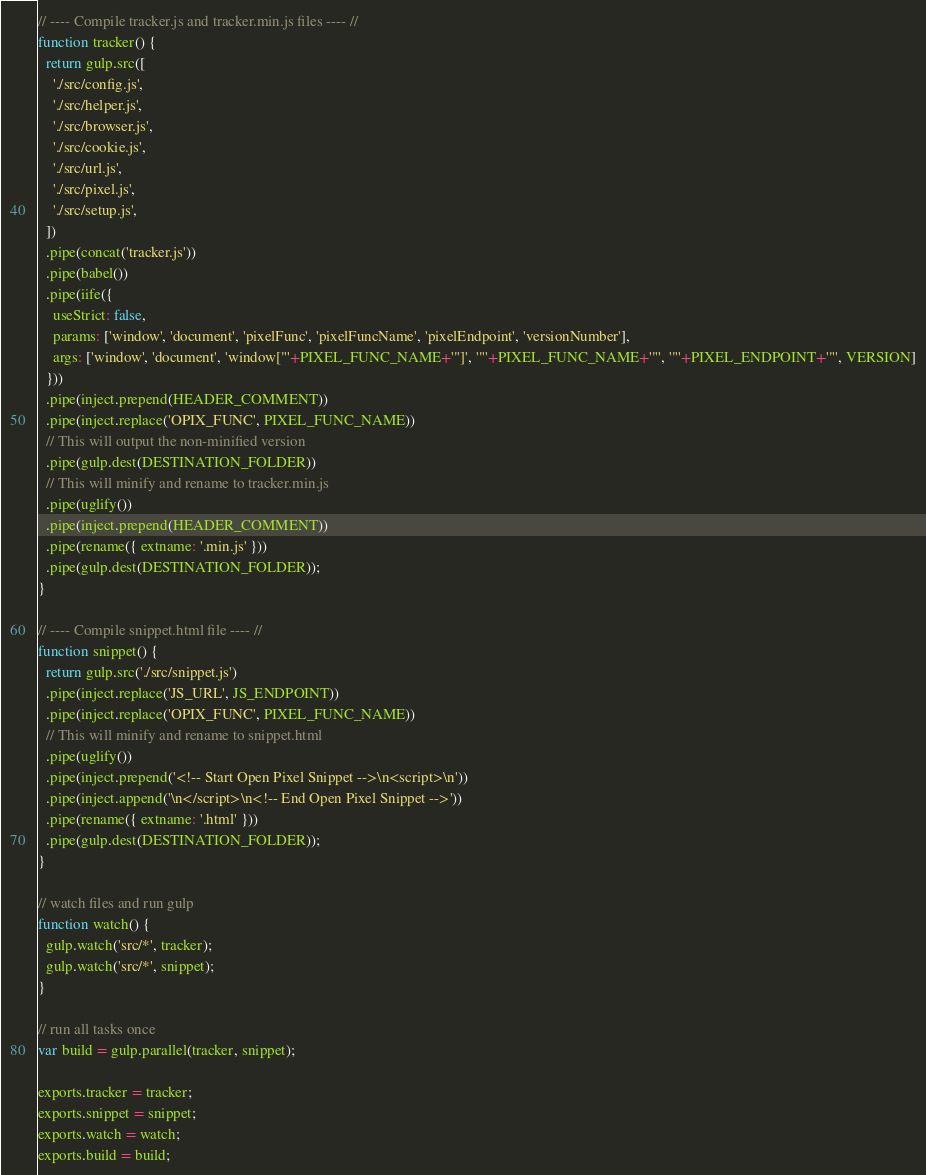<code> <loc_0><loc_0><loc_500><loc_500><_JavaScript_>// ---- Compile tracker.js and tracker.min.js files ---- //
function tracker() {
  return gulp.src([
    './src/config.js',
    './src/helper.js',
    './src/browser.js',
    './src/cookie.js',
    './src/url.js',
    './src/pixel.js',
    './src/setup.js',
  ])
  .pipe(concat('tracker.js'))
  .pipe(babel())
  .pipe(iife({
    useStrict: false,
    params: ['window', 'document', 'pixelFunc', 'pixelFuncName', 'pixelEndpoint', 'versionNumber'],
    args: ['window', 'document', 'window["'+PIXEL_FUNC_NAME+'"]', '"'+PIXEL_FUNC_NAME+'"', '"'+PIXEL_ENDPOINT+'"', VERSION]
  }))
  .pipe(inject.prepend(HEADER_COMMENT))
  .pipe(inject.replace('OPIX_FUNC', PIXEL_FUNC_NAME))
  // This will output the non-minified version
  .pipe(gulp.dest(DESTINATION_FOLDER))
  // This will minify and rename to tracker.min.js
  .pipe(uglify())
  .pipe(inject.prepend(HEADER_COMMENT))
  .pipe(rename({ extname: '.min.js' }))
  .pipe(gulp.dest(DESTINATION_FOLDER));
}

// ---- Compile snippet.html file ---- //
function snippet() {
  return gulp.src('./src/snippet.js')
  .pipe(inject.replace('JS_URL', JS_ENDPOINT))
  .pipe(inject.replace('OPIX_FUNC', PIXEL_FUNC_NAME))
  // This will minify and rename to snippet.html
  .pipe(uglify())
  .pipe(inject.prepend('<!-- Start Open Pixel Snippet -->\n<script>\n'))
  .pipe(inject.append('\n</script>\n<!-- End Open Pixel Snippet -->'))
  .pipe(rename({ extname: '.html' }))
  .pipe(gulp.dest(DESTINATION_FOLDER));
}

// watch files and run gulp
function watch() {
  gulp.watch('src/*', tracker);
  gulp.watch('src/*', snippet);
}

// run all tasks once
var build = gulp.parallel(tracker, snippet);

exports.tracker = tracker;
exports.snippet = snippet;
exports.watch = watch;
exports.build = build;
</code> 